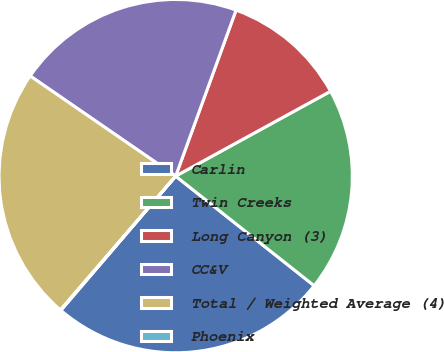<chart> <loc_0><loc_0><loc_500><loc_500><pie_chart><fcel>Carlin<fcel>Twin Creeks<fcel>Long Canyon (3)<fcel>CC&V<fcel>Total / Weighted Average (4)<fcel>Phoenix<nl><fcel>25.61%<fcel>18.63%<fcel>11.47%<fcel>20.96%<fcel>23.28%<fcel>0.05%<nl></chart> 